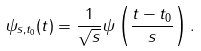<formula> <loc_0><loc_0><loc_500><loc_500>\psi _ { s , t _ { 0 } } ( t ) = \frac { 1 } { \sqrt { s } } \psi \left ( \frac { t - t _ { 0 } } { s } \right ) .</formula> 